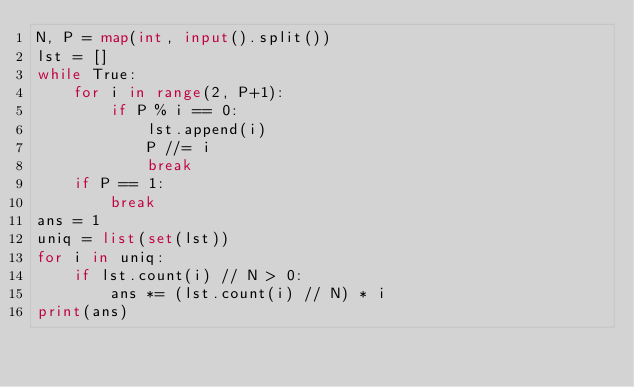<code> <loc_0><loc_0><loc_500><loc_500><_Python_>N, P = map(int, input().split())
lst = []
while True:
    for i in range(2, P+1):
        if P % i == 0:
            lst.append(i)
            P //= i
            break
    if P == 1:
        break
ans = 1
uniq = list(set(lst))
for i in uniq:
    if lst.count(i) // N > 0:
        ans *= (lst.count(i) // N) * i
print(ans)
</code> 